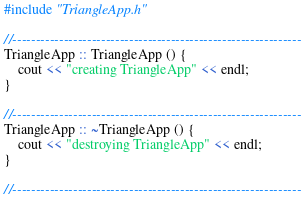<code> <loc_0><loc_0><loc_500><loc_500><_ObjectiveC_>#include "TriangleApp.h"

//--------------------------------------------------------------
TriangleApp :: TriangleApp () {
    cout << "creating TriangleApp" << endl;
}

//--------------------------------------------------------------
TriangleApp :: ~TriangleApp () {
    cout << "destroying TriangleApp" << endl;
}

//--------------------------------------------------------------</code> 